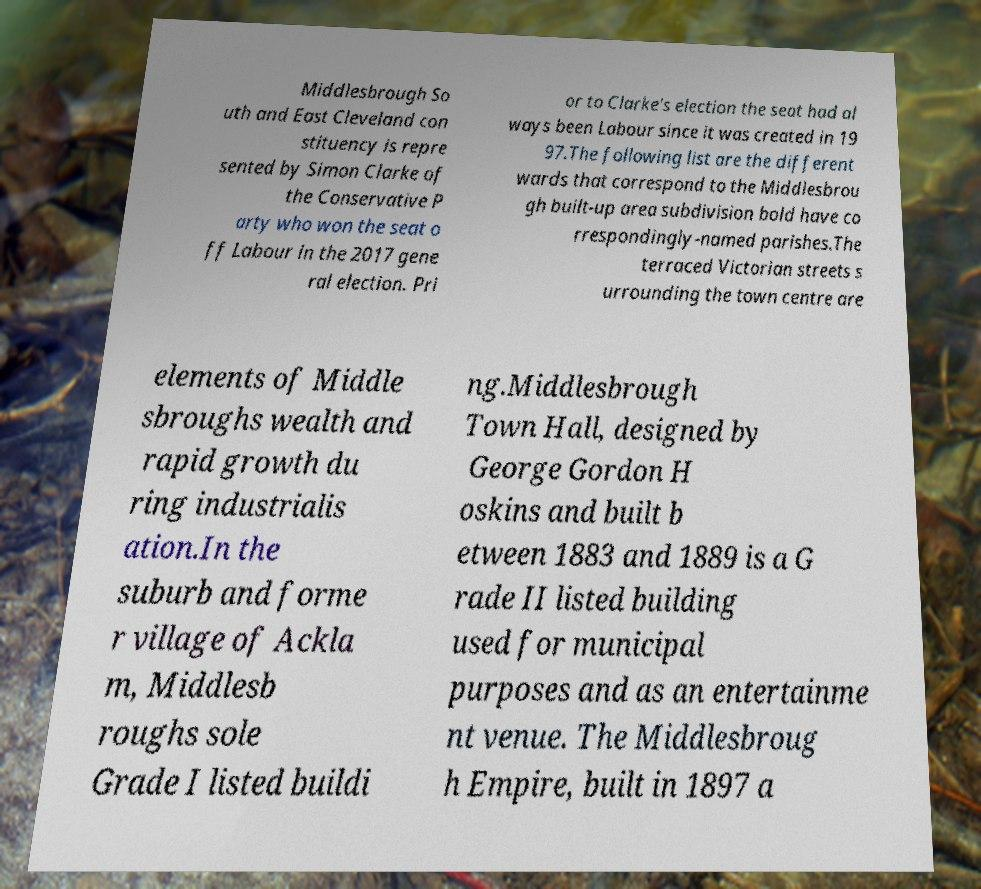Can you read and provide the text displayed in the image?This photo seems to have some interesting text. Can you extract and type it out for me? Middlesbrough So uth and East Cleveland con stituency is repre sented by Simon Clarke of the Conservative P arty who won the seat o ff Labour in the 2017 gene ral election. Pri or to Clarke's election the seat had al ways been Labour since it was created in 19 97.The following list are the different wards that correspond to the Middlesbrou gh built-up area subdivision bold have co rrespondingly-named parishes.The terraced Victorian streets s urrounding the town centre are elements of Middle sbroughs wealth and rapid growth du ring industrialis ation.In the suburb and forme r village of Ackla m, Middlesb roughs sole Grade I listed buildi ng.Middlesbrough Town Hall, designed by George Gordon H oskins and built b etween 1883 and 1889 is a G rade II listed building used for municipal purposes and as an entertainme nt venue. The Middlesbroug h Empire, built in 1897 a 